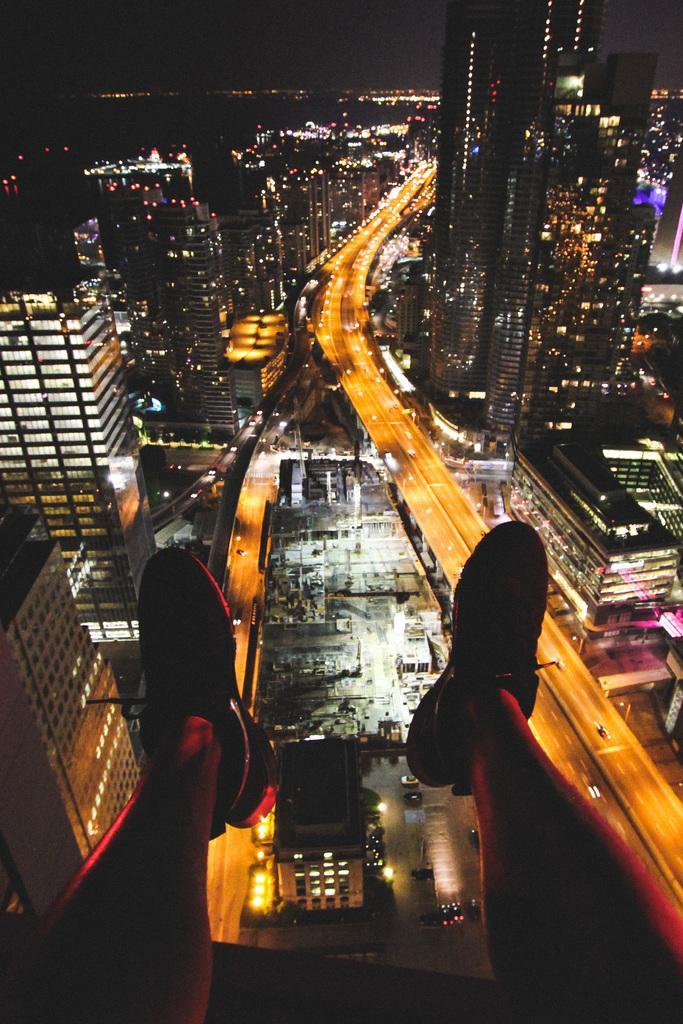Can you describe this image briefly? This image consists of a man sitting on the terrace. In the front, there are legs of a person who is wearing shoes. In the background, there are many buildings and skyscrapers along with lights and roads. 